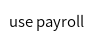Convert code to text. <code><loc_0><loc_0><loc_500><loc_500><_SQL_>use payroll

</code> 